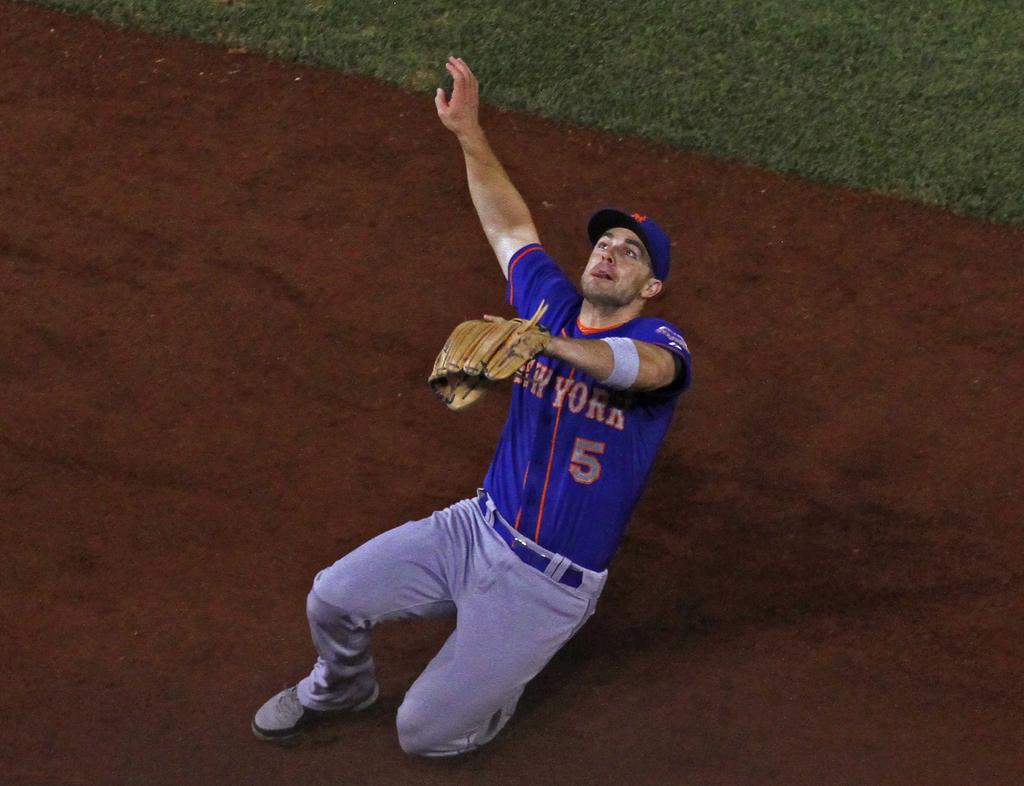<image>
Present a compact description of the photo's key features. The new york player falls as he tries to get the ball. 